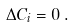Convert formula to latex. <formula><loc_0><loc_0><loc_500><loc_500>\Delta C _ { i } = 0 \, .</formula> 